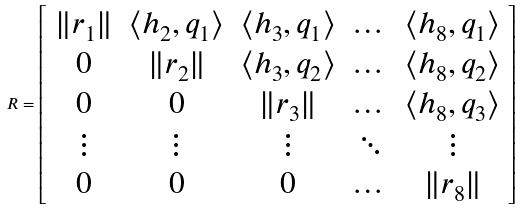<formula> <loc_0><loc_0><loc_500><loc_500>R = \left [ \begin{array} { c c c c c } \| r _ { 1 } \| & \langle h _ { 2 } , q _ { 1 } \rangle & \langle h _ { 3 } , q _ { 1 } \rangle & \dots & \langle h _ { 8 } , q _ { 1 } \rangle \\ 0 & \| r _ { 2 } \| & \langle h _ { 3 } , q _ { 2 } \rangle & \dots & \langle h _ { 8 } , q _ { 2 } \rangle \\ 0 & 0 & \| r _ { 3 } \| & \dots & \langle h _ { 8 } , q _ { 3 } \rangle \\ \vdots & \vdots & \vdots & \ddots & \vdots \\ 0 & 0 & 0 & \dots & \| r _ { 8 } \| \\ \end{array} \right ]</formula> 